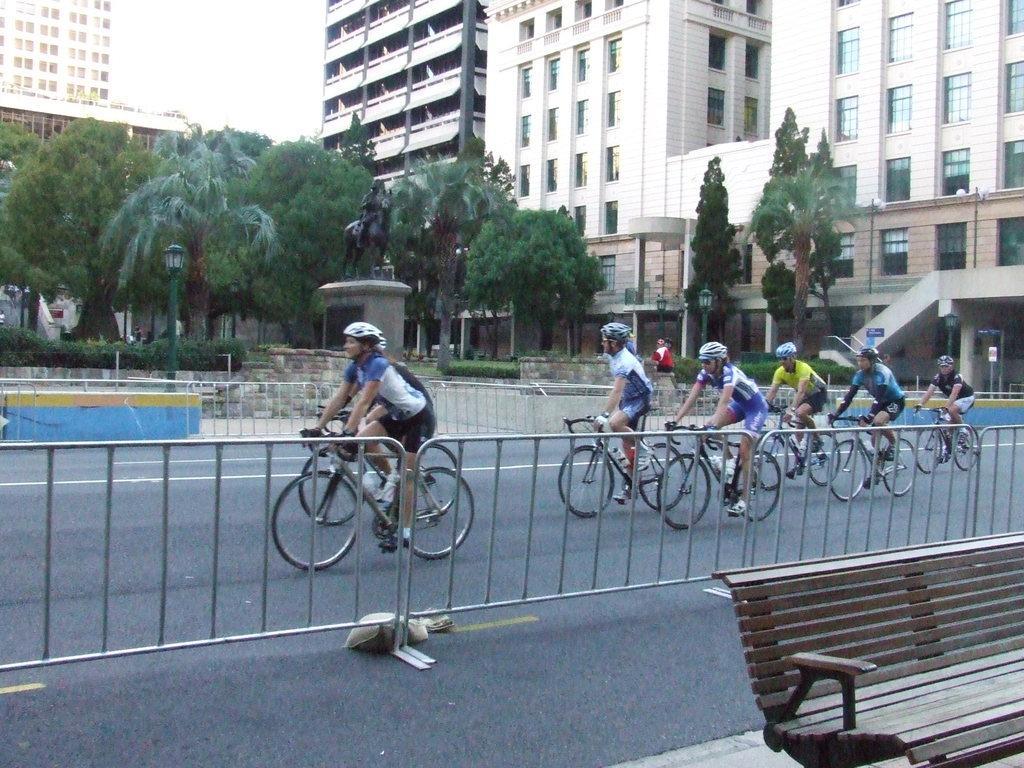Could you give a brief overview of what you see in this image? In this image, we can see few people are riding bicycles on the road. They are wearing glasses and helmets. At the bottom, we can see a bench. Here we can see barricades. Background there are so many buildings, trees, statue, poles, lights, plants. Here we can see a person. 